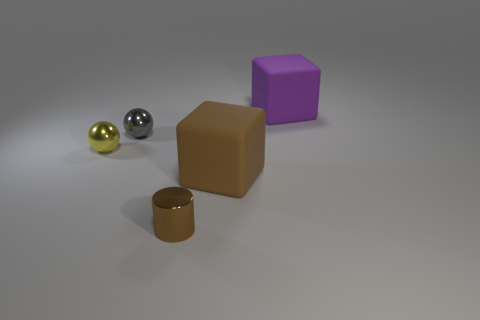What color is the small metallic cylinder?
Provide a succinct answer. Brown. What is the shape of the object on the right side of the brown thing on the right side of the small brown shiny thing?
Make the answer very short. Cube. Is there another small cylinder made of the same material as the cylinder?
Provide a short and direct response. No. There is a metal ball on the left side of the gray metal object; does it have the same size as the small brown metallic thing?
Ensure brevity in your answer.  Yes. What number of gray objects are big objects or small shiny cylinders?
Your answer should be very brief. 0. There is a brown thing that is to the right of the small brown thing; what is its material?
Your answer should be very brief. Rubber. How many tiny shiny things are to the left of the metal ball in front of the small gray shiny object?
Provide a short and direct response. 0. What number of small yellow metallic things are the same shape as the big brown thing?
Make the answer very short. 0. How many big cyan metallic spheres are there?
Offer a terse response. 0. There is a large cube in front of the yellow ball; what is its color?
Ensure brevity in your answer.  Brown. 